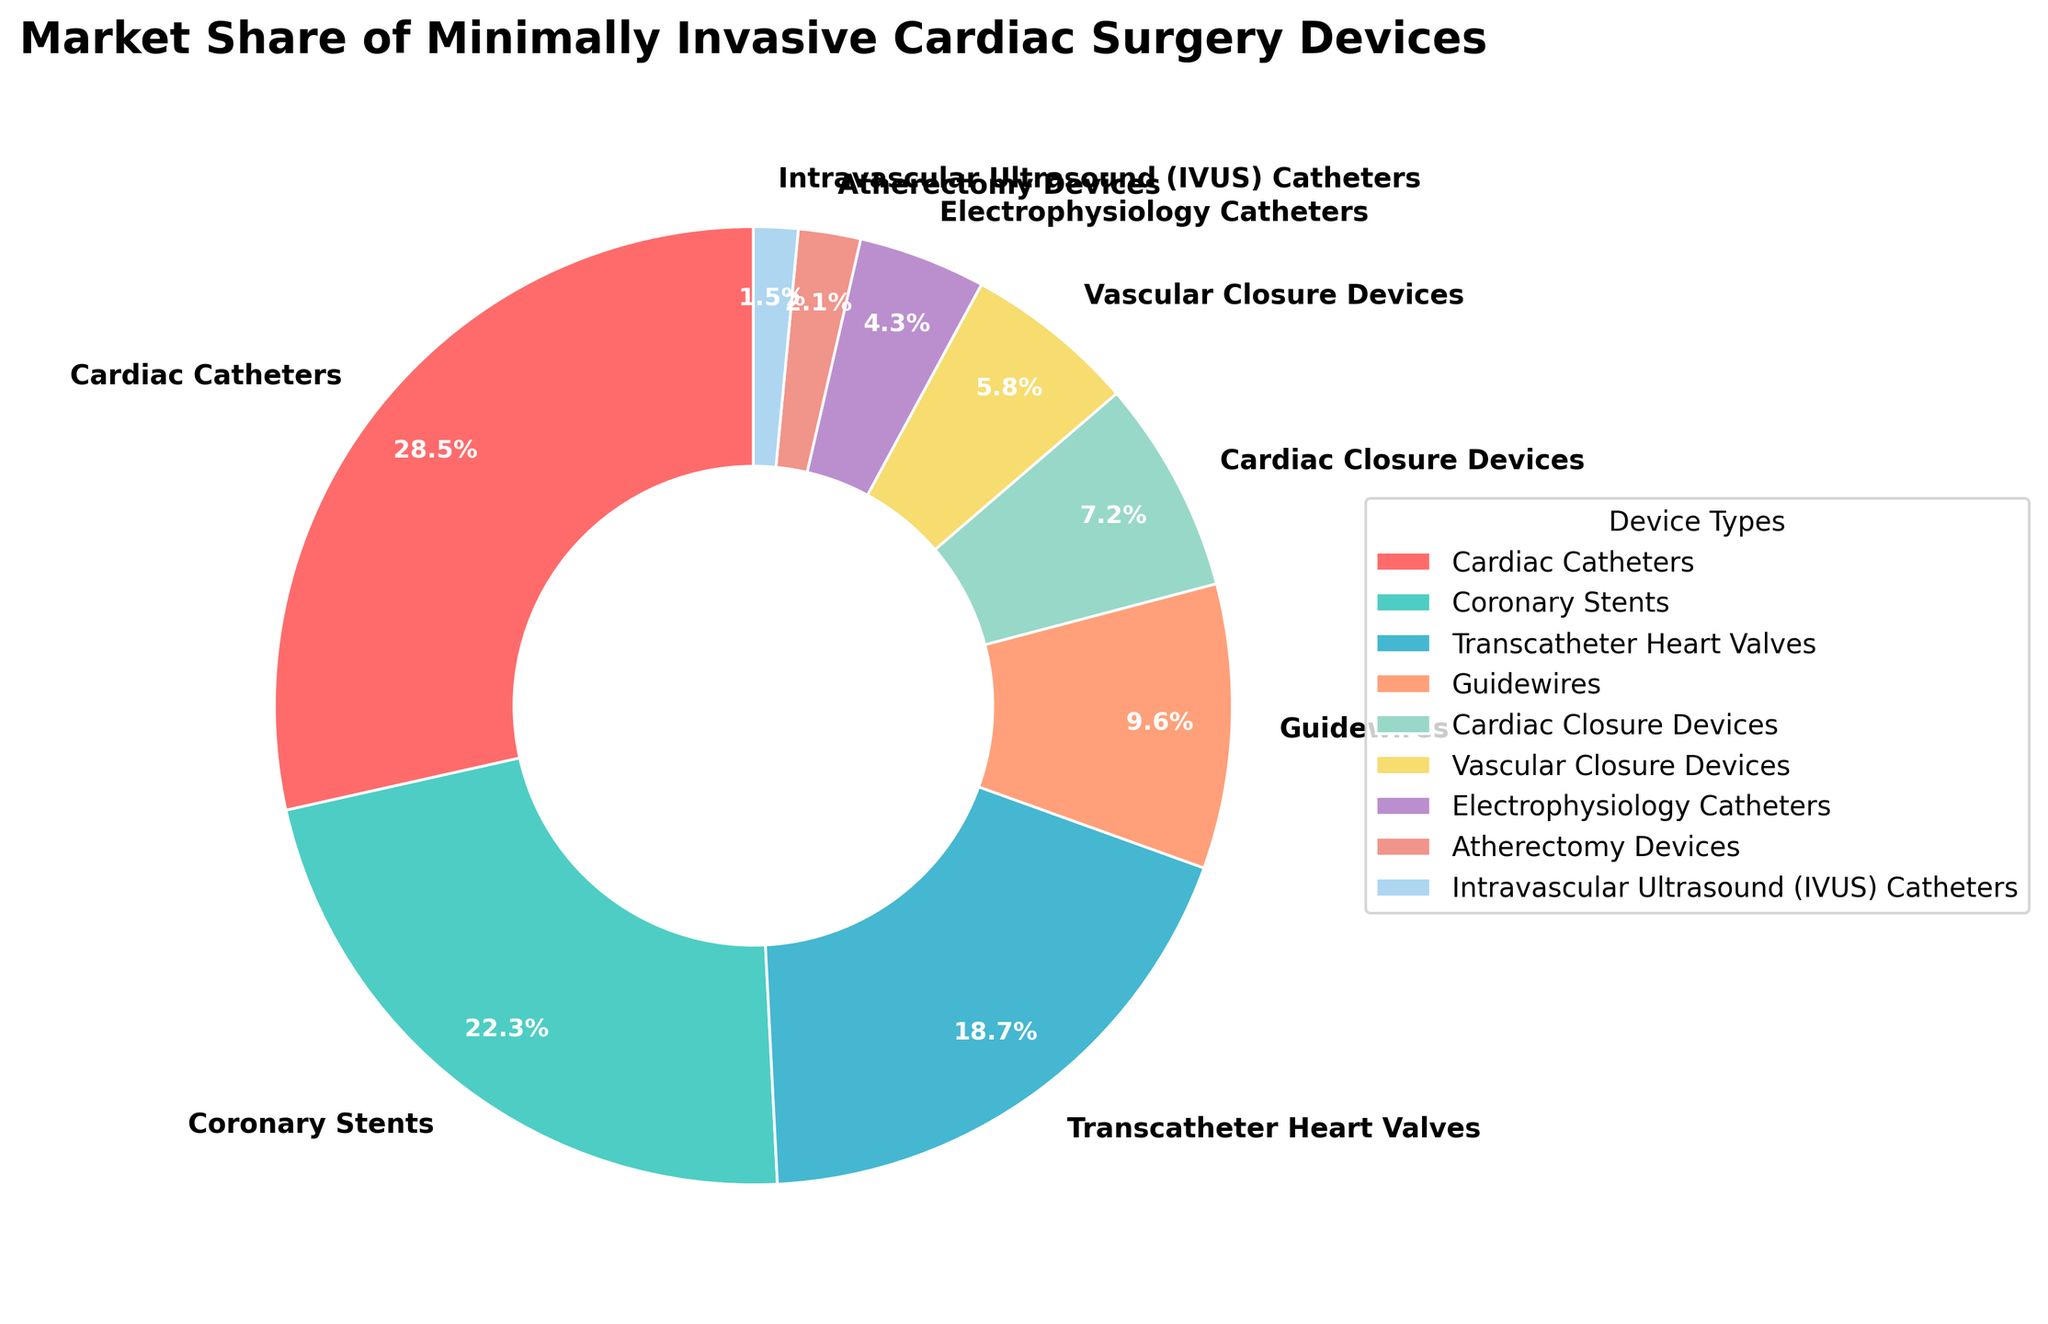What is the market share of the device type with the highest share? By visually identifying the largest segment in the pie chart, we can see that Cardiac Catheters has the largest market share, which is 28.5%.
Answer: 28.5% Which device type has the smallest market share? By finding the smallest segment in the pie chart, we can see that Intravascular Ultrasound (IVUS) Catheters has the smallest market share, which is 1.5%.
Answer: 1.5% What is the total market share percentage of devices classified as catheters? The devices classified as catheters are Cardiac Catheters (28.5%) and Electrophysiology Catheters (4.3%). Adding these two shares gives 28.5% + 4.3% = 32.8%.
Answer: 32.8% How much larger is the market share of Cardiac Catheters compared to Coronary Stents? Cardiac Catheters have a market share of 28.5%, and Coronary Stents have a market share of 22.3%. The difference is 28.5% - 22.3% = 6.2%.
Answer: 6.2% If we combine the market shares of Transcatheter Heart Valves and Guidewires, what percentage do they represent together? Transcatheter Heart Valves have a market share of 18.7%, and Guidewires have a market share of 9.6%. Adding these together gives 18.7% + 9.6% = 28.3%.
Answer: 28.3% Which device types together constitute more than 50% of the market share? By summing the market shares starting from the largest slice until we surpass 50%: Cardiac Catheters (28.5%) + Coronary Stents (22.3%) = 50.8%, which means these two device types together exceed 50%.
Answer: Cardiac Catheters, Coronary Stents What is the difference in market share between the largest and smallest device types? The largest market share is Cardiac Catheters (28.5%), and the smallest market share is Intravascular Ultrasound (IVUS) Catheters (1.5%). The difference is 28.5% - 1.5% = 27%.
Answer: 27% How do the shares of Cardiac Catheters and Transcatheter Heart Valves compare visually? Visually, the segment representing Cardiac Catheters is significantly larger than the segment representing Transcatheter Heart Valves, reflecting their respective market shares of 28.5% and 18.7%.
Answer: Cardiac Catheters are significantly larger What is the combined market share of Vascular Closure Devices and Cardiac Closure Devices? The market share of Vascular Closure Devices is 5.8%, and that of Cardiac Closure Devices is 7.2%. Adding these together gives 5.8% + 7.2% = 13%.
Answer: 13% Which device type has a market share closer to 10%? Guidewires have a market share of 9.6%, which is closest to 10% when compared to other device types.
Answer: Guidewires 